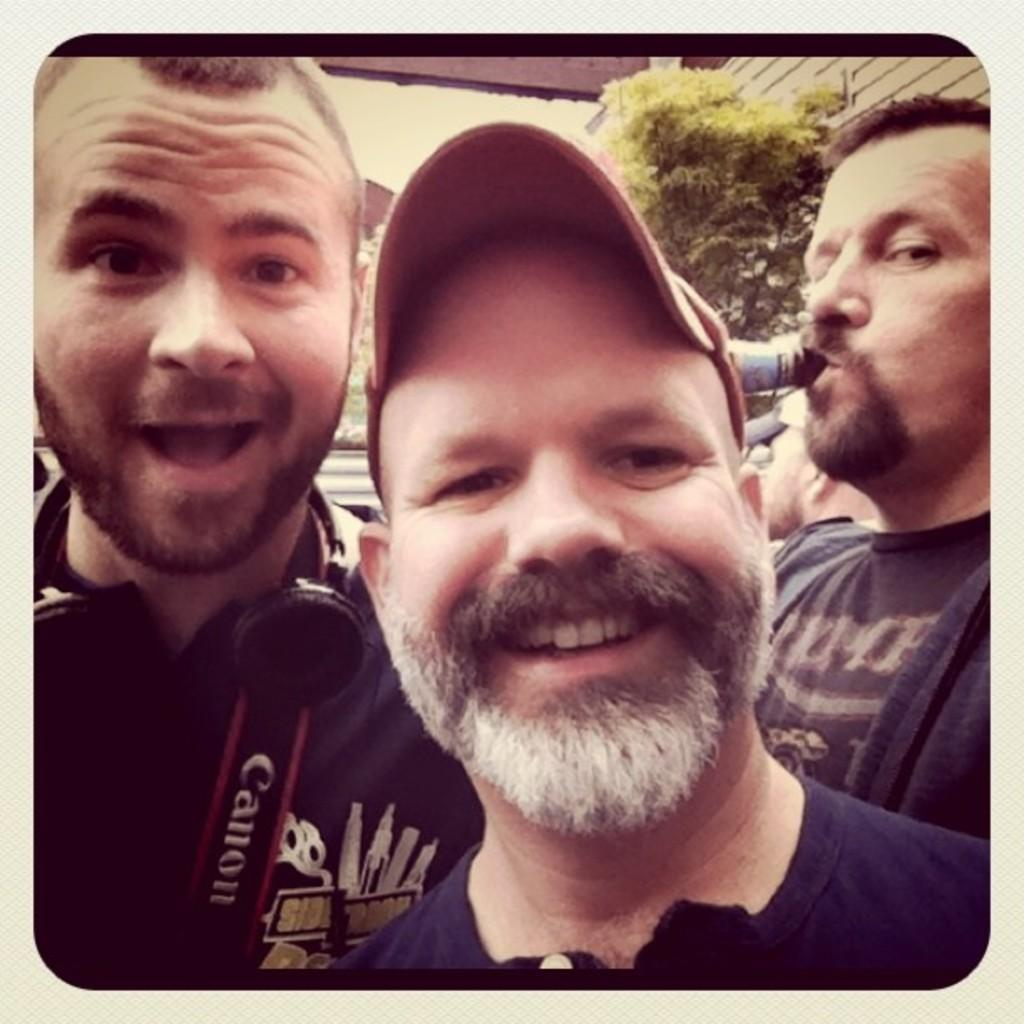What is the main subject in the middle of the image? There is a man in the middle of the image. What is the man in the middle doing? The man in the middle is smiling. What is the man in the middle wearing on his head? The man in the middle is wearing a cap. Are there any other people in the image? Yes, there is a man on the right side of the image. What is the man on the right side doing? The man on the right side has a beer bottle in his mouth. Reasoning: Let' Let's think step by step in order to produce the conversation. We start by identifying the main subject in the image, which is the man in the middle. Then, we describe his facial expression and what he is wearing. Next, we acknowledge the presence of another person in the image and describe what he is doing. Each question is designed to elicit a specific detail about the image that is known from the provided facts. Absurd Question/Answer: What type of boat can be seen on the stage in the image? There is no boat or stage present in the image. What is the profit margin for the man in the image? There is no information about profit margins in the image. 